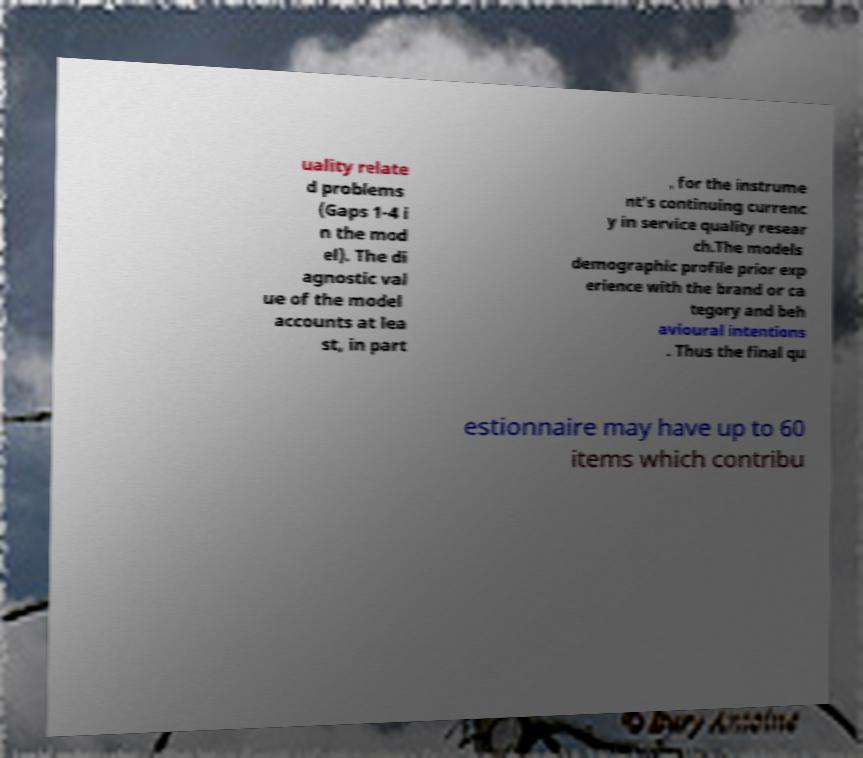Can you read and provide the text displayed in the image?This photo seems to have some interesting text. Can you extract and type it out for me? uality relate d problems (Gaps 1-4 i n the mod el). The di agnostic val ue of the model accounts at lea st, in part , for the instrume nt's continuing currenc y in service quality resear ch.The models demographic profile prior exp erience with the brand or ca tegory and beh avioural intentions . Thus the final qu estionnaire may have up to 60 items which contribu 